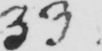What is written in this line of handwriting? 33 . 